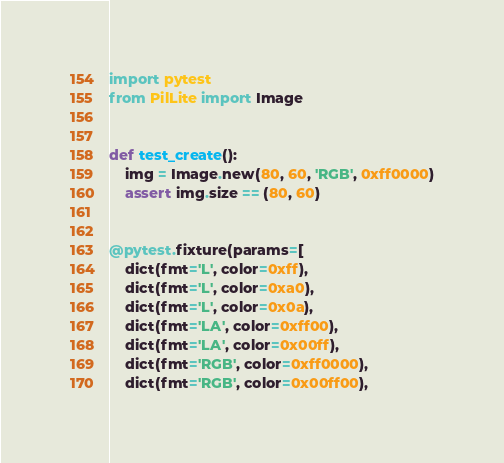<code> <loc_0><loc_0><loc_500><loc_500><_Python_>import pytest
from PilLite import Image


def test_create():
    img = Image.new(80, 60, 'RGB', 0xff0000)
    assert img.size == (80, 60)


@pytest.fixture(params=[
    dict(fmt='L', color=0xff),
    dict(fmt='L', color=0xa0),
    dict(fmt='L', color=0x0a),
    dict(fmt='LA', color=0xff00),
    dict(fmt='LA', color=0x00ff),
    dict(fmt='RGB', color=0xff0000),
    dict(fmt='RGB', color=0x00ff00),</code> 